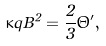Convert formula to latex. <formula><loc_0><loc_0><loc_500><loc_500>\kappa q B ^ { 2 } = \frac { 2 } { 3 } \Theta ^ { \prime } ,</formula> 